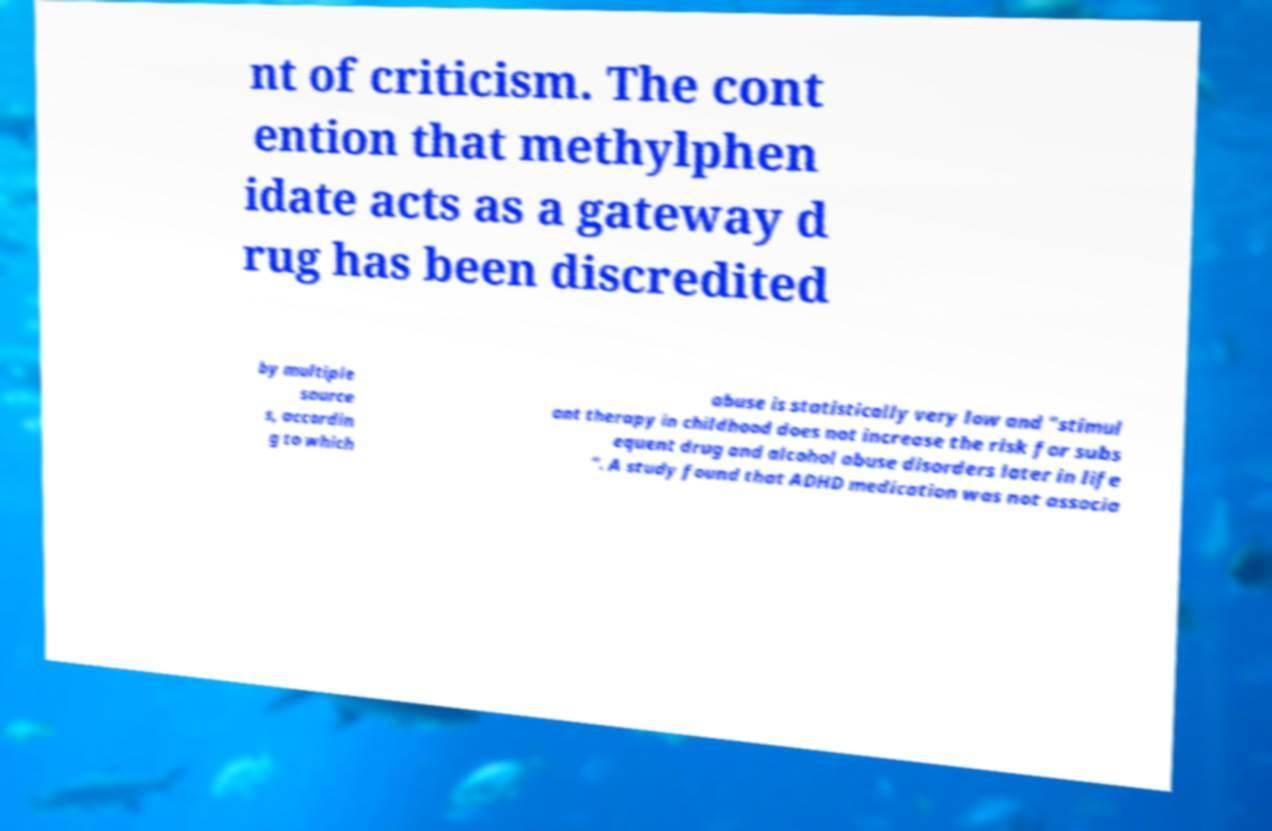Can you accurately transcribe the text from the provided image for me? nt of criticism. The cont ention that methylphen idate acts as a gateway d rug has been discredited by multiple source s, accordin g to which abuse is statistically very low and "stimul ant therapy in childhood does not increase the risk for subs equent drug and alcohol abuse disorders later in life ". A study found that ADHD medication was not associa 